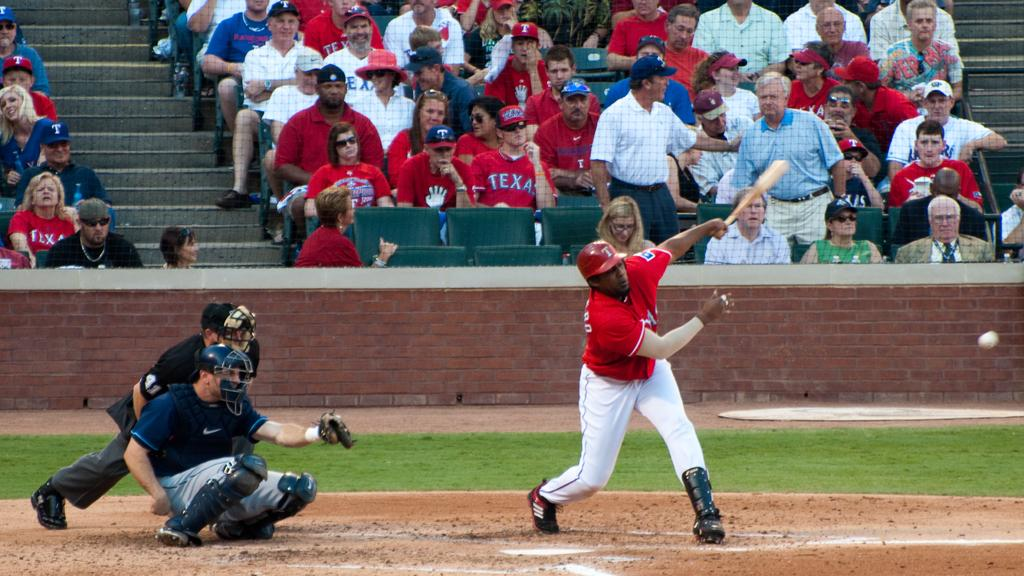Provide a one-sentence caption for the provided image. Several people in the crowd at a baseball game are wearing red Texas shirts. 